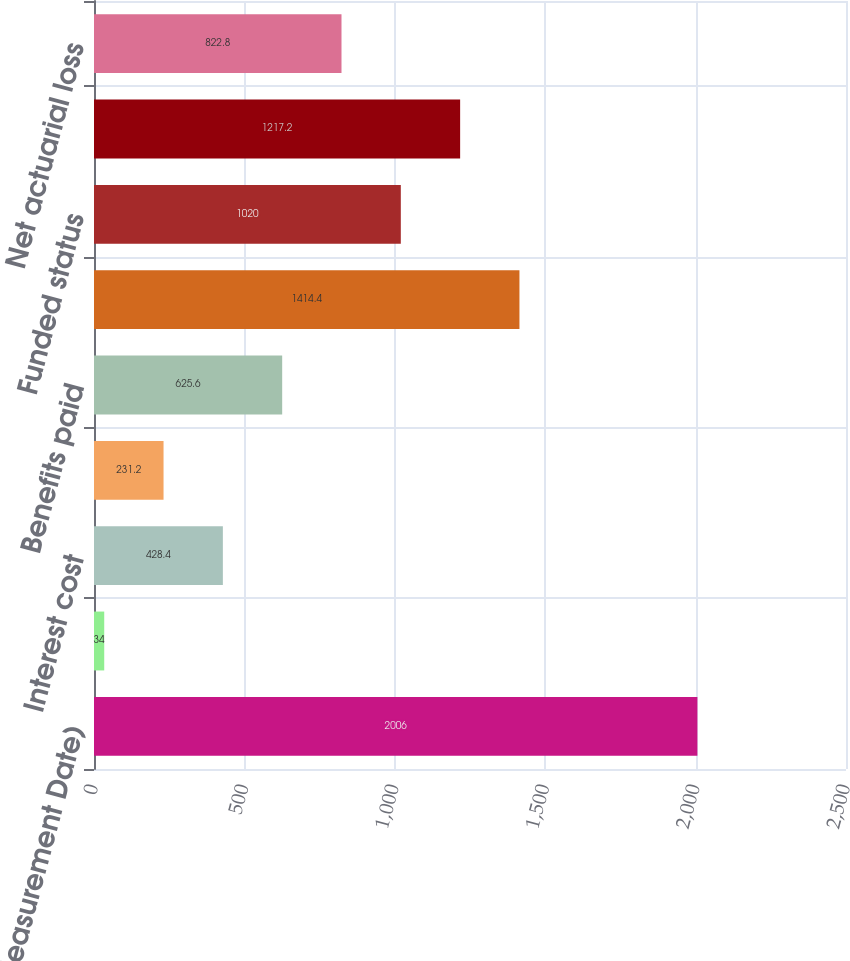Convert chart to OTSL. <chart><loc_0><loc_0><loc_500><loc_500><bar_chart><fcel>December 31 (Measurement Date)<fcel>Service cost<fcel>Interest cost<fcel>Actuarial loss (gain)<fcel>Benefits paid<fcel>Projected benefit obligation<fcel>Funded status<fcel>Net amount recognized on the<fcel>Net actuarial loss<nl><fcel>2006<fcel>34<fcel>428.4<fcel>231.2<fcel>625.6<fcel>1414.4<fcel>1020<fcel>1217.2<fcel>822.8<nl></chart> 